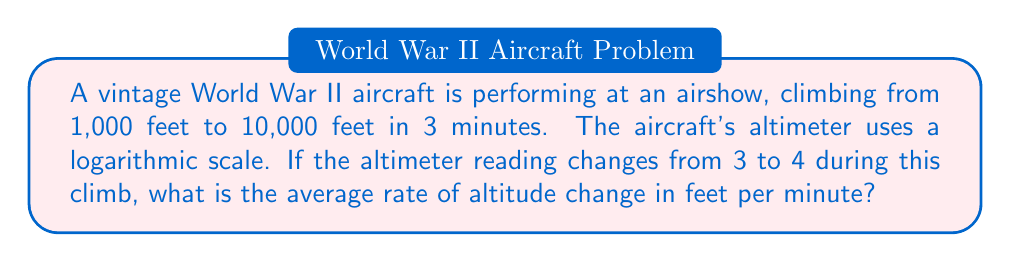Could you help me with this problem? Let's approach this step-by-step:

1) The altimeter uses a logarithmic scale, so we need to convert the readings to actual altitudes:
   
   $10^3 = 1,000$ feet (initial altitude)
   $10^4 = 10,000$ feet (final altitude)

2) The total change in altitude is:
   
   $\Delta h = 10,000 - 1,000 = 9,000$ feet

3) The time taken for this climb is 3 minutes.

4) To calculate the average rate of change, we use the formula:

   $$\text{Rate} = \frac{\text{Change in altitude}}{\text{Time taken}}$$

5) Plugging in our values:

   $$\text{Rate} = \frac{9,000 \text{ feet}}{3 \text{ minutes}} = 3,000 \text{ feet/minute}$$

This problem demonstrates how logarithmic scales are used in aviation instruments to display a wide range of values in a compact space, which is crucial for cockpit design in vintage aircraft.
Answer: 3,000 feet/minute 